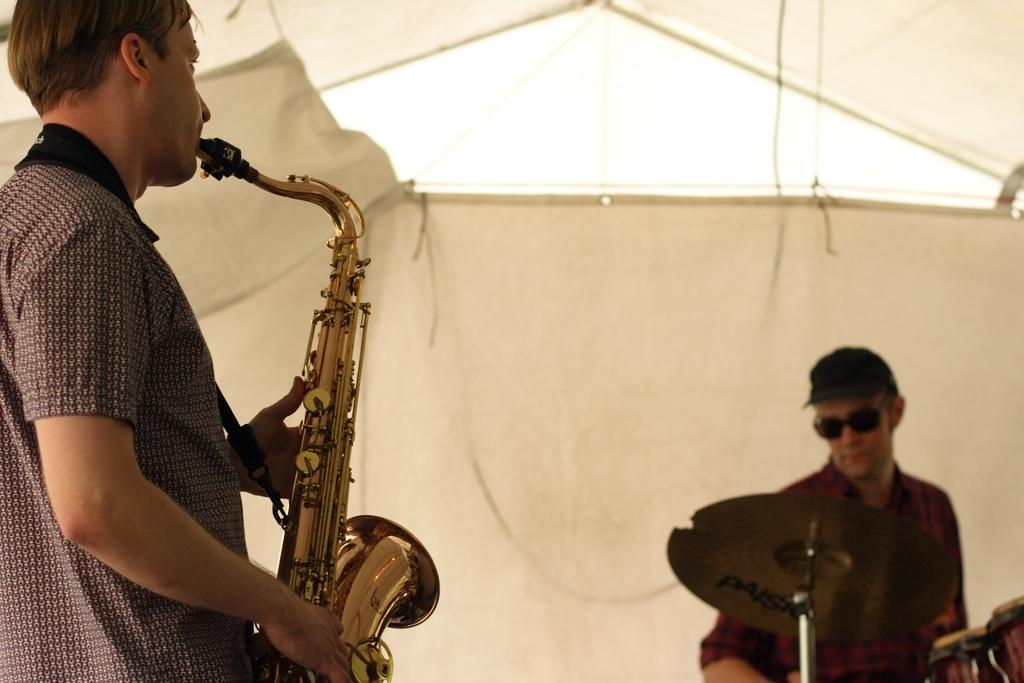How many people are in the image? There are two men in the image. What are the men doing in the image? Both men are playing musical instruments. Can you describe the appearance of the man on the right side of the image? The man on the right side of the image is wearing a hat and black color shades. What type of cheese can be seen on the line in the image? There is no cheese or line present in the image. What color is the paste that the men are using to play their instruments? The men are not using any paste to play their instruments; they are playing musical instruments with their hands or other tools. 